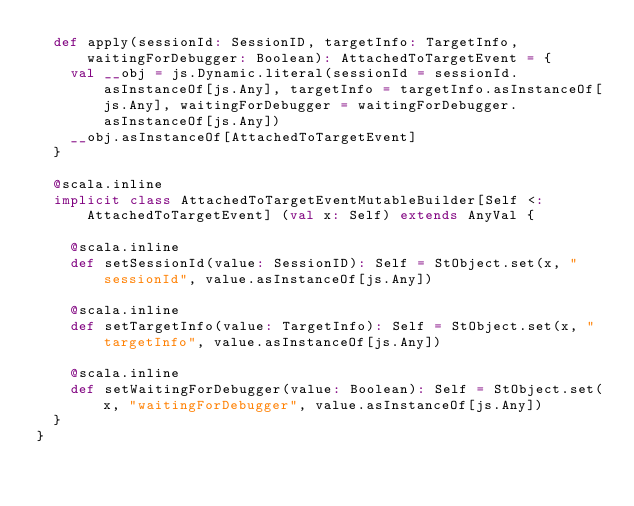Convert code to text. <code><loc_0><loc_0><loc_500><loc_500><_Scala_>  def apply(sessionId: SessionID, targetInfo: TargetInfo, waitingForDebugger: Boolean): AttachedToTargetEvent = {
    val __obj = js.Dynamic.literal(sessionId = sessionId.asInstanceOf[js.Any], targetInfo = targetInfo.asInstanceOf[js.Any], waitingForDebugger = waitingForDebugger.asInstanceOf[js.Any])
    __obj.asInstanceOf[AttachedToTargetEvent]
  }
  
  @scala.inline
  implicit class AttachedToTargetEventMutableBuilder[Self <: AttachedToTargetEvent] (val x: Self) extends AnyVal {
    
    @scala.inline
    def setSessionId(value: SessionID): Self = StObject.set(x, "sessionId", value.asInstanceOf[js.Any])
    
    @scala.inline
    def setTargetInfo(value: TargetInfo): Self = StObject.set(x, "targetInfo", value.asInstanceOf[js.Any])
    
    @scala.inline
    def setWaitingForDebugger(value: Boolean): Self = StObject.set(x, "waitingForDebugger", value.asInstanceOf[js.Any])
  }
}
</code> 